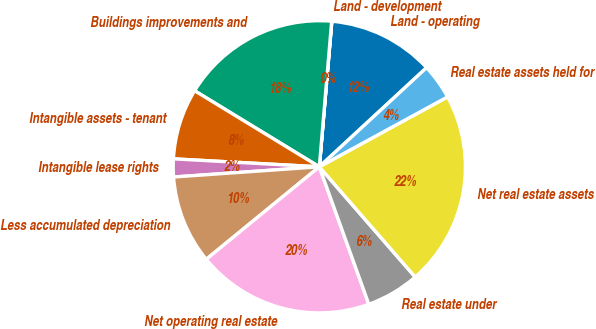Convert chart to OTSL. <chart><loc_0><loc_0><loc_500><loc_500><pie_chart><fcel>Land - operating<fcel>Land - development<fcel>Buildings improvements and<fcel>Intangible assets - tenant<fcel>Intangible lease rights<fcel>Less accumulated depreciation<fcel>Net operating real estate<fcel>Real estate under<fcel>Net real estate assets<fcel>Real estate assets held for<nl><fcel>11.76%<fcel>0.02%<fcel>17.63%<fcel>7.85%<fcel>1.98%<fcel>9.8%<fcel>19.59%<fcel>5.89%<fcel>21.55%<fcel>3.93%<nl></chart> 